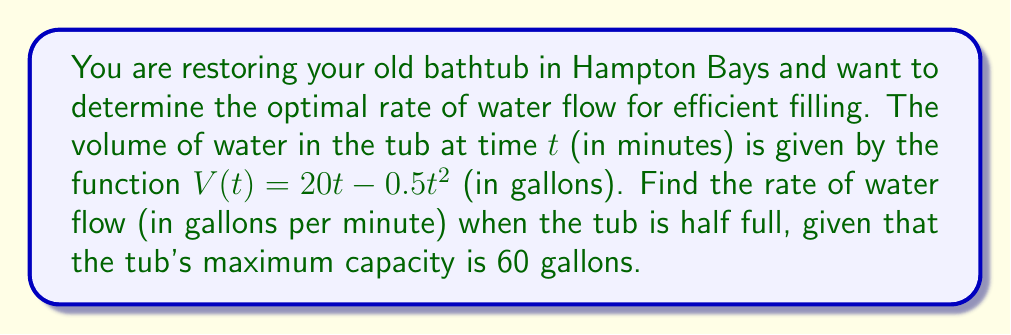Can you answer this question? To solve this problem, we'll follow these steps:

1) First, we need to find when the tub is half full. The tub's maximum capacity is 60 gallons, so it's half full at 30 gallons.

2) We need to find the time $t$ when $V(t) = 30$:

   $30 = 20t - 0.5t^2$

   This is a quadratic equation. Let's solve it:

   $0.5t^2 - 20t + 30 = 0$

   Using the quadratic formula: $t = \frac{-b \pm \sqrt{b^2 - 4ac}}{2a}$

   $t = \frac{20 \pm \sqrt{400 - 60}}{1} = \frac{20 \pm \sqrt{340}}{1}$

   $t \approx 17.36$ or $2.64$

   Since we're filling the tub, we'll use the smaller value: $t \approx 2.64$ minutes.

3) To find the rate of water flow, we need to find the derivative of $V(t)$:

   $V'(t) = 20 - t$

4) Now we can calculate the rate of flow when $t \approx 2.64$:

   $V'(2.64) = 20 - 2.64 \approx 17.36$

Therefore, when the tub is half full, the rate of water flow is approximately 17.36 gallons per minute.
Answer: $17.36$ gallons per minute 